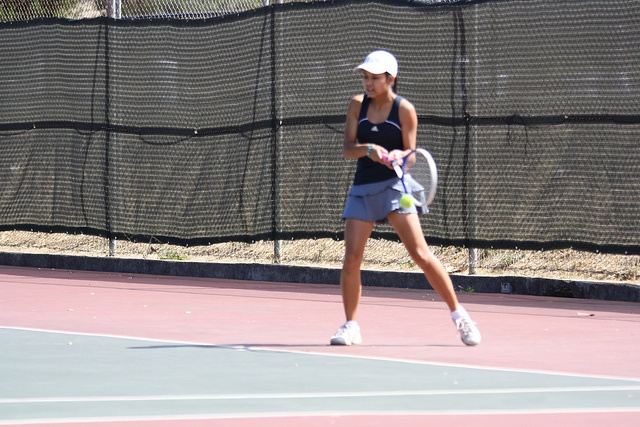Describe the objects in this image and their specific colors. I can see people in gray, white, black, and brown tones, tennis racket in gray and lavender tones, and sports ball in gray, khaki, beige, and lightgreen tones in this image. 